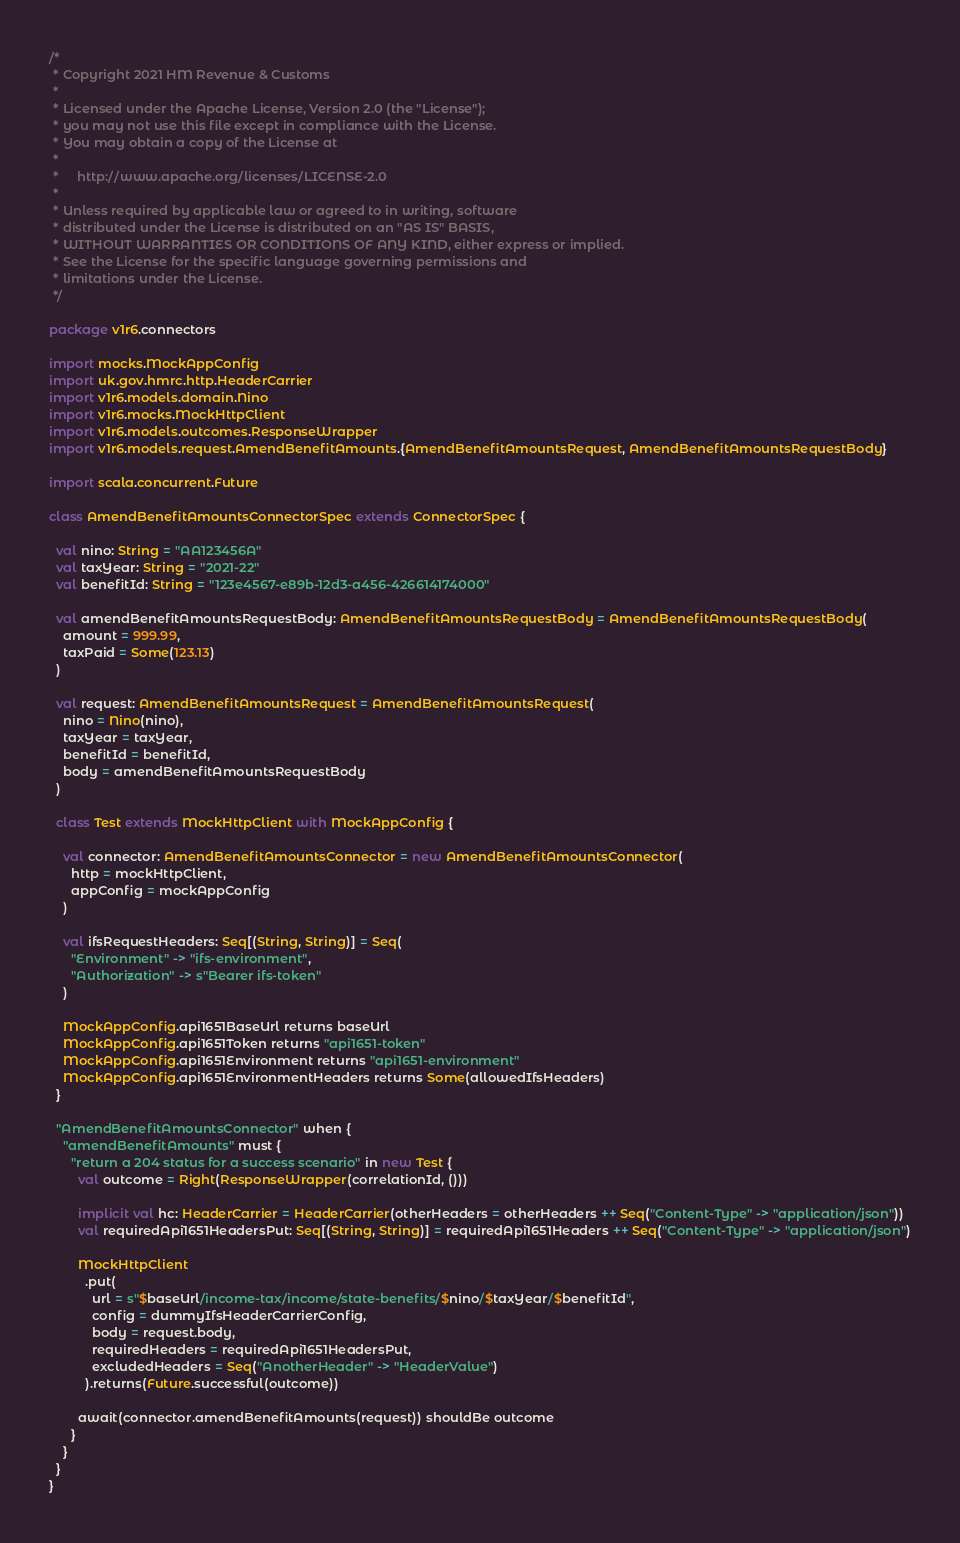Convert code to text. <code><loc_0><loc_0><loc_500><loc_500><_Scala_>/*
 * Copyright 2021 HM Revenue & Customs
 *
 * Licensed under the Apache License, Version 2.0 (the "License");
 * you may not use this file except in compliance with the License.
 * You may obtain a copy of the License at
 *
 *     http://www.apache.org/licenses/LICENSE-2.0
 *
 * Unless required by applicable law or agreed to in writing, software
 * distributed under the License is distributed on an "AS IS" BASIS,
 * WITHOUT WARRANTIES OR CONDITIONS OF ANY KIND, either express or implied.
 * See the License for the specific language governing permissions and
 * limitations under the License.
 */

package v1r6.connectors

import mocks.MockAppConfig
import uk.gov.hmrc.http.HeaderCarrier
import v1r6.models.domain.Nino
import v1r6.mocks.MockHttpClient
import v1r6.models.outcomes.ResponseWrapper
import v1r6.models.request.AmendBenefitAmounts.{AmendBenefitAmountsRequest, AmendBenefitAmountsRequestBody}

import scala.concurrent.Future

class AmendBenefitAmountsConnectorSpec extends ConnectorSpec {

  val nino: String = "AA123456A"
  val taxYear: String = "2021-22"
  val benefitId: String = "123e4567-e89b-12d3-a456-426614174000"

  val amendBenefitAmountsRequestBody: AmendBenefitAmountsRequestBody = AmendBenefitAmountsRequestBody(
    amount = 999.99,
    taxPaid = Some(123.13)
  )

  val request: AmendBenefitAmountsRequest = AmendBenefitAmountsRequest(
    nino = Nino(nino),
    taxYear = taxYear,
    benefitId = benefitId,
    body = amendBenefitAmountsRequestBody
  )

  class Test extends MockHttpClient with MockAppConfig {

    val connector: AmendBenefitAmountsConnector = new AmendBenefitAmountsConnector(
      http = mockHttpClient,
      appConfig = mockAppConfig
    )

    val ifsRequestHeaders: Seq[(String, String)] = Seq(
      "Environment" -> "ifs-environment",
      "Authorization" -> s"Bearer ifs-token"
    )

    MockAppConfig.api1651BaseUrl returns baseUrl
    MockAppConfig.api1651Token returns "api1651-token"
    MockAppConfig.api1651Environment returns "api1651-environment"
    MockAppConfig.api1651EnvironmentHeaders returns Some(allowedIfsHeaders)
  }

  "AmendBenefitAmountsConnector" when {
    "amendBenefitAmounts" must {
      "return a 204 status for a success scenario" in new Test {
        val outcome = Right(ResponseWrapper(correlationId, ()))

        implicit val hc: HeaderCarrier = HeaderCarrier(otherHeaders = otherHeaders ++ Seq("Content-Type" -> "application/json"))
        val requiredApi1651HeadersPut: Seq[(String, String)] = requiredApi1651Headers ++ Seq("Content-Type" -> "application/json")

        MockHttpClient
          .put(
            url = s"$baseUrl/income-tax/income/state-benefits/$nino/$taxYear/$benefitId",
            config = dummyIfsHeaderCarrierConfig,
            body = request.body,
            requiredHeaders = requiredApi1651HeadersPut,
            excludedHeaders = Seq("AnotherHeader" -> "HeaderValue")
          ).returns(Future.successful(outcome))

        await(connector.amendBenefitAmounts(request)) shouldBe outcome
      }
    }
  }
}
</code> 